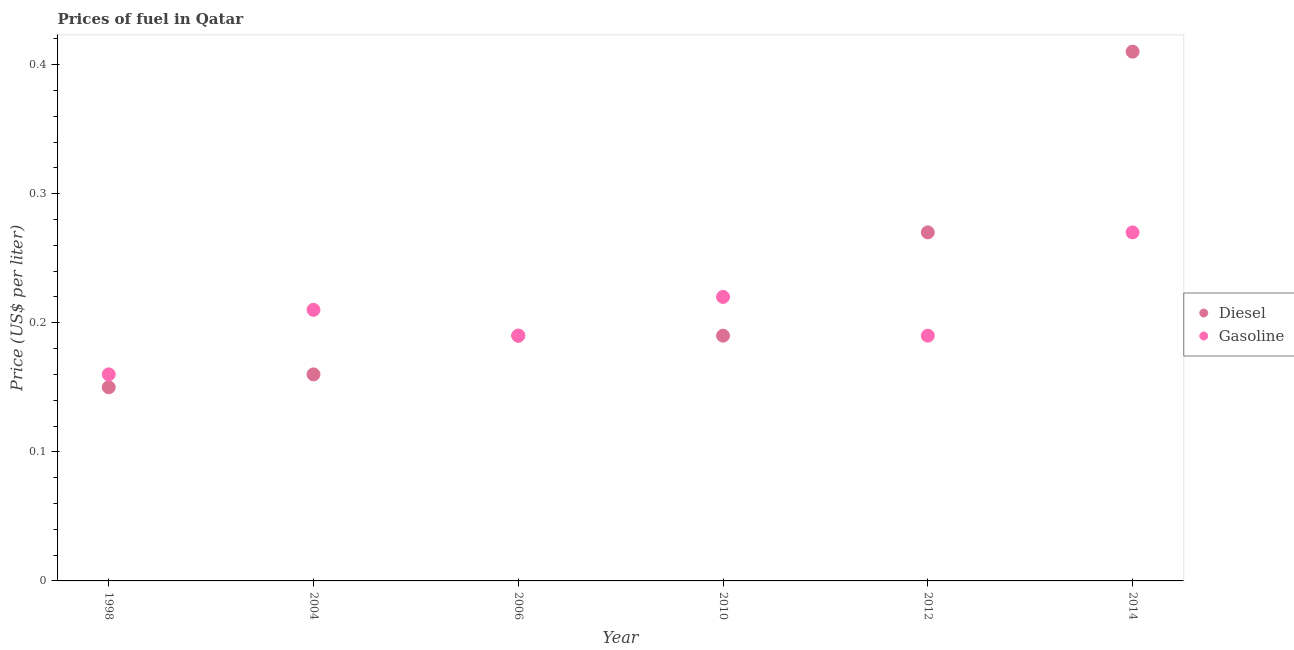What is the gasoline price in 2012?
Offer a terse response. 0.19. Across all years, what is the maximum diesel price?
Provide a short and direct response. 0.41. Across all years, what is the minimum gasoline price?
Your response must be concise. 0.16. In which year was the diesel price maximum?
Offer a terse response. 2014. In which year was the gasoline price minimum?
Give a very brief answer. 1998. What is the total gasoline price in the graph?
Your answer should be very brief. 1.24. What is the difference between the diesel price in 2006 and that in 2012?
Your answer should be compact. -0.08. What is the difference between the diesel price in 2006 and the gasoline price in 2004?
Offer a very short reply. -0.02. What is the average gasoline price per year?
Offer a very short reply. 0.21. In the year 1998, what is the difference between the diesel price and gasoline price?
Offer a terse response. -0.01. In how many years, is the diesel price greater than 0.2 US$ per litre?
Your answer should be very brief. 2. What is the ratio of the gasoline price in 2010 to that in 2012?
Your answer should be compact. 1.16. Is the gasoline price in 2010 less than that in 2012?
Your answer should be very brief. No. Is the difference between the gasoline price in 2006 and 2012 greater than the difference between the diesel price in 2006 and 2012?
Ensure brevity in your answer.  Yes. What is the difference between the highest and the second highest gasoline price?
Your answer should be very brief. 0.05. What is the difference between the highest and the lowest diesel price?
Provide a short and direct response. 0.26. In how many years, is the diesel price greater than the average diesel price taken over all years?
Offer a very short reply. 2. Does the gasoline price monotonically increase over the years?
Offer a terse response. No. Is the diesel price strictly greater than the gasoline price over the years?
Your answer should be compact. No. Is the diesel price strictly less than the gasoline price over the years?
Give a very brief answer. No. How many years are there in the graph?
Provide a short and direct response. 6. Are the values on the major ticks of Y-axis written in scientific E-notation?
Provide a succinct answer. No. Does the graph contain grids?
Your answer should be compact. No. How are the legend labels stacked?
Give a very brief answer. Vertical. What is the title of the graph?
Ensure brevity in your answer.  Prices of fuel in Qatar. What is the label or title of the Y-axis?
Provide a short and direct response. Price (US$ per liter). What is the Price (US$ per liter) in Diesel in 1998?
Keep it short and to the point. 0.15. What is the Price (US$ per liter) in Gasoline in 1998?
Your answer should be very brief. 0.16. What is the Price (US$ per liter) of Diesel in 2004?
Your response must be concise. 0.16. What is the Price (US$ per liter) of Gasoline in 2004?
Give a very brief answer. 0.21. What is the Price (US$ per liter) in Diesel in 2006?
Give a very brief answer. 0.19. What is the Price (US$ per liter) in Gasoline in 2006?
Keep it short and to the point. 0.19. What is the Price (US$ per liter) of Diesel in 2010?
Keep it short and to the point. 0.19. What is the Price (US$ per liter) of Gasoline in 2010?
Provide a short and direct response. 0.22. What is the Price (US$ per liter) in Diesel in 2012?
Your answer should be compact. 0.27. What is the Price (US$ per liter) of Gasoline in 2012?
Your answer should be very brief. 0.19. What is the Price (US$ per liter) of Diesel in 2014?
Offer a terse response. 0.41. What is the Price (US$ per liter) of Gasoline in 2014?
Keep it short and to the point. 0.27. Across all years, what is the maximum Price (US$ per liter) of Diesel?
Ensure brevity in your answer.  0.41. Across all years, what is the maximum Price (US$ per liter) of Gasoline?
Provide a succinct answer. 0.27. Across all years, what is the minimum Price (US$ per liter) of Gasoline?
Make the answer very short. 0.16. What is the total Price (US$ per liter) of Diesel in the graph?
Give a very brief answer. 1.37. What is the total Price (US$ per liter) in Gasoline in the graph?
Provide a short and direct response. 1.24. What is the difference between the Price (US$ per liter) of Diesel in 1998 and that in 2004?
Provide a succinct answer. -0.01. What is the difference between the Price (US$ per liter) in Gasoline in 1998 and that in 2004?
Ensure brevity in your answer.  -0.05. What is the difference between the Price (US$ per liter) in Diesel in 1998 and that in 2006?
Offer a very short reply. -0.04. What is the difference between the Price (US$ per liter) of Gasoline in 1998 and that in 2006?
Offer a very short reply. -0.03. What is the difference between the Price (US$ per liter) of Diesel in 1998 and that in 2010?
Ensure brevity in your answer.  -0.04. What is the difference between the Price (US$ per liter) in Gasoline in 1998 and that in 2010?
Offer a terse response. -0.06. What is the difference between the Price (US$ per liter) of Diesel in 1998 and that in 2012?
Offer a very short reply. -0.12. What is the difference between the Price (US$ per liter) in Gasoline in 1998 and that in 2012?
Keep it short and to the point. -0.03. What is the difference between the Price (US$ per liter) in Diesel in 1998 and that in 2014?
Ensure brevity in your answer.  -0.26. What is the difference between the Price (US$ per liter) of Gasoline in 1998 and that in 2014?
Offer a very short reply. -0.11. What is the difference between the Price (US$ per liter) in Diesel in 2004 and that in 2006?
Offer a very short reply. -0.03. What is the difference between the Price (US$ per liter) in Diesel in 2004 and that in 2010?
Ensure brevity in your answer.  -0.03. What is the difference between the Price (US$ per liter) in Gasoline in 2004 and that in 2010?
Provide a succinct answer. -0.01. What is the difference between the Price (US$ per liter) in Diesel in 2004 and that in 2012?
Keep it short and to the point. -0.11. What is the difference between the Price (US$ per liter) in Gasoline in 2004 and that in 2012?
Your response must be concise. 0.02. What is the difference between the Price (US$ per liter) of Diesel in 2004 and that in 2014?
Give a very brief answer. -0.25. What is the difference between the Price (US$ per liter) of Gasoline in 2004 and that in 2014?
Give a very brief answer. -0.06. What is the difference between the Price (US$ per liter) of Gasoline in 2006 and that in 2010?
Provide a short and direct response. -0.03. What is the difference between the Price (US$ per liter) in Diesel in 2006 and that in 2012?
Offer a terse response. -0.08. What is the difference between the Price (US$ per liter) of Diesel in 2006 and that in 2014?
Your answer should be compact. -0.22. What is the difference between the Price (US$ per liter) in Gasoline in 2006 and that in 2014?
Ensure brevity in your answer.  -0.08. What is the difference between the Price (US$ per liter) in Diesel in 2010 and that in 2012?
Your answer should be compact. -0.08. What is the difference between the Price (US$ per liter) of Gasoline in 2010 and that in 2012?
Give a very brief answer. 0.03. What is the difference between the Price (US$ per liter) in Diesel in 2010 and that in 2014?
Offer a terse response. -0.22. What is the difference between the Price (US$ per liter) in Gasoline in 2010 and that in 2014?
Offer a terse response. -0.05. What is the difference between the Price (US$ per liter) of Diesel in 2012 and that in 2014?
Your answer should be very brief. -0.14. What is the difference between the Price (US$ per liter) of Gasoline in 2012 and that in 2014?
Offer a very short reply. -0.08. What is the difference between the Price (US$ per liter) of Diesel in 1998 and the Price (US$ per liter) of Gasoline in 2004?
Ensure brevity in your answer.  -0.06. What is the difference between the Price (US$ per liter) in Diesel in 1998 and the Price (US$ per liter) in Gasoline in 2006?
Your response must be concise. -0.04. What is the difference between the Price (US$ per liter) of Diesel in 1998 and the Price (US$ per liter) of Gasoline in 2010?
Make the answer very short. -0.07. What is the difference between the Price (US$ per liter) of Diesel in 1998 and the Price (US$ per liter) of Gasoline in 2012?
Make the answer very short. -0.04. What is the difference between the Price (US$ per liter) in Diesel in 1998 and the Price (US$ per liter) in Gasoline in 2014?
Ensure brevity in your answer.  -0.12. What is the difference between the Price (US$ per liter) in Diesel in 2004 and the Price (US$ per liter) in Gasoline in 2006?
Your response must be concise. -0.03. What is the difference between the Price (US$ per liter) in Diesel in 2004 and the Price (US$ per liter) in Gasoline in 2010?
Make the answer very short. -0.06. What is the difference between the Price (US$ per liter) in Diesel in 2004 and the Price (US$ per liter) in Gasoline in 2012?
Your answer should be compact. -0.03. What is the difference between the Price (US$ per liter) of Diesel in 2004 and the Price (US$ per liter) of Gasoline in 2014?
Offer a very short reply. -0.11. What is the difference between the Price (US$ per liter) in Diesel in 2006 and the Price (US$ per liter) in Gasoline in 2010?
Make the answer very short. -0.03. What is the difference between the Price (US$ per liter) of Diesel in 2006 and the Price (US$ per liter) of Gasoline in 2014?
Keep it short and to the point. -0.08. What is the difference between the Price (US$ per liter) of Diesel in 2010 and the Price (US$ per liter) of Gasoline in 2012?
Provide a short and direct response. 0. What is the difference between the Price (US$ per liter) of Diesel in 2010 and the Price (US$ per liter) of Gasoline in 2014?
Your answer should be compact. -0.08. What is the average Price (US$ per liter) of Diesel per year?
Keep it short and to the point. 0.23. What is the average Price (US$ per liter) in Gasoline per year?
Ensure brevity in your answer.  0.21. In the year 1998, what is the difference between the Price (US$ per liter) of Diesel and Price (US$ per liter) of Gasoline?
Make the answer very short. -0.01. In the year 2010, what is the difference between the Price (US$ per liter) of Diesel and Price (US$ per liter) of Gasoline?
Your response must be concise. -0.03. In the year 2014, what is the difference between the Price (US$ per liter) in Diesel and Price (US$ per liter) in Gasoline?
Provide a short and direct response. 0.14. What is the ratio of the Price (US$ per liter) of Diesel in 1998 to that in 2004?
Your answer should be compact. 0.94. What is the ratio of the Price (US$ per liter) in Gasoline in 1998 to that in 2004?
Provide a short and direct response. 0.76. What is the ratio of the Price (US$ per liter) of Diesel in 1998 to that in 2006?
Offer a terse response. 0.79. What is the ratio of the Price (US$ per liter) in Gasoline in 1998 to that in 2006?
Ensure brevity in your answer.  0.84. What is the ratio of the Price (US$ per liter) of Diesel in 1998 to that in 2010?
Provide a short and direct response. 0.79. What is the ratio of the Price (US$ per liter) of Gasoline in 1998 to that in 2010?
Your answer should be compact. 0.73. What is the ratio of the Price (US$ per liter) in Diesel in 1998 to that in 2012?
Your answer should be compact. 0.56. What is the ratio of the Price (US$ per liter) of Gasoline in 1998 to that in 2012?
Provide a short and direct response. 0.84. What is the ratio of the Price (US$ per liter) of Diesel in 1998 to that in 2014?
Your answer should be compact. 0.37. What is the ratio of the Price (US$ per liter) in Gasoline in 1998 to that in 2014?
Your answer should be compact. 0.59. What is the ratio of the Price (US$ per liter) in Diesel in 2004 to that in 2006?
Your response must be concise. 0.84. What is the ratio of the Price (US$ per liter) of Gasoline in 2004 to that in 2006?
Offer a very short reply. 1.11. What is the ratio of the Price (US$ per liter) of Diesel in 2004 to that in 2010?
Your answer should be very brief. 0.84. What is the ratio of the Price (US$ per liter) of Gasoline in 2004 to that in 2010?
Your answer should be compact. 0.95. What is the ratio of the Price (US$ per liter) in Diesel in 2004 to that in 2012?
Make the answer very short. 0.59. What is the ratio of the Price (US$ per liter) in Gasoline in 2004 to that in 2012?
Provide a succinct answer. 1.11. What is the ratio of the Price (US$ per liter) of Diesel in 2004 to that in 2014?
Offer a very short reply. 0.39. What is the ratio of the Price (US$ per liter) in Gasoline in 2004 to that in 2014?
Your answer should be very brief. 0.78. What is the ratio of the Price (US$ per liter) in Gasoline in 2006 to that in 2010?
Provide a short and direct response. 0.86. What is the ratio of the Price (US$ per liter) of Diesel in 2006 to that in 2012?
Ensure brevity in your answer.  0.7. What is the ratio of the Price (US$ per liter) in Gasoline in 2006 to that in 2012?
Make the answer very short. 1. What is the ratio of the Price (US$ per liter) in Diesel in 2006 to that in 2014?
Provide a succinct answer. 0.46. What is the ratio of the Price (US$ per liter) of Gasoline in 2006 to that in 2014?
Keep it short and to the point. 0.7. What is the ratio of the Price (US$ per liter) in Diesel in 2010 to that in 2012?
Ensure brevity in your answer.  0.7. What is the ratio of the Price (US$ per liter) in Gasoline in 2010 to that in 2012?
Provide a short and direct response. 1.16. What is the ratio of the Price (US$ per liter) of Diesel in 2010 to that in 2014?
Provide a succinct answer. 0.46. What is the ratio of the Price (US$ per liter) of Gasoline in 2010 to that in 2014?
Your answer should be very brief. 0.81. What is the ratio of the Price (US$ per liter) of Diesel in 2012 to that in 2014?
Provide a succinct answer. 0.66. What is the ratio of the Price (US$ per liter) in Gasoline in 2012 to that in 2014?
Give a very brief answer. 0.7. What is the difference between the highest and the second highest Price (US$ per liter) of Diesel?
Your response must be concise. 0.14. What is the difference between the highest and the lowest Price (US$ per liter) in Diesel?
Your answer should be compact. 0.26. What is the difference between the highest and the lowest Price (US$ per liter) of Gasoline?
Make the answer very short. 0.11. 